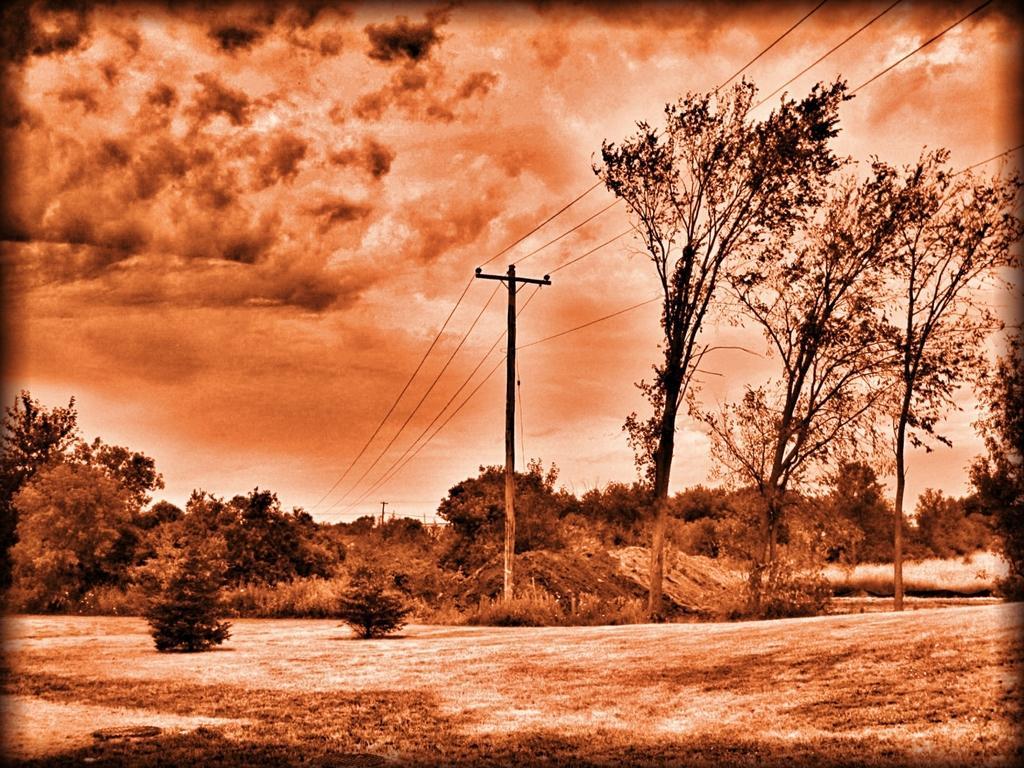In one or two sentences, can you explain what this image depicts? This image is taken outdoors. It is an edited image. At the bottom of the image there is a ground with grass on it. At the top of the image there is a sky with clouds. In the background there are many trees and plants and there is a pole with wires. 